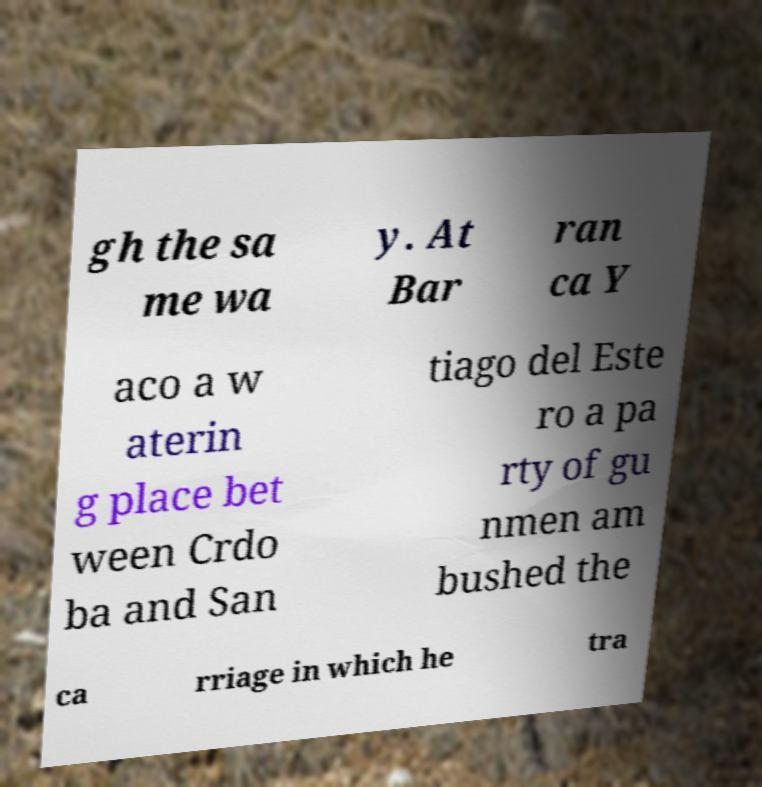Can you accurately transcribe the text from the provided image for me? gh the sa me wa y. At Bar ran ca Y aco a w aterin g place bet ween Crdo ba and San tiago del Este ro a pa rty of gu nmen am bushed the ca rriage in which he tra 